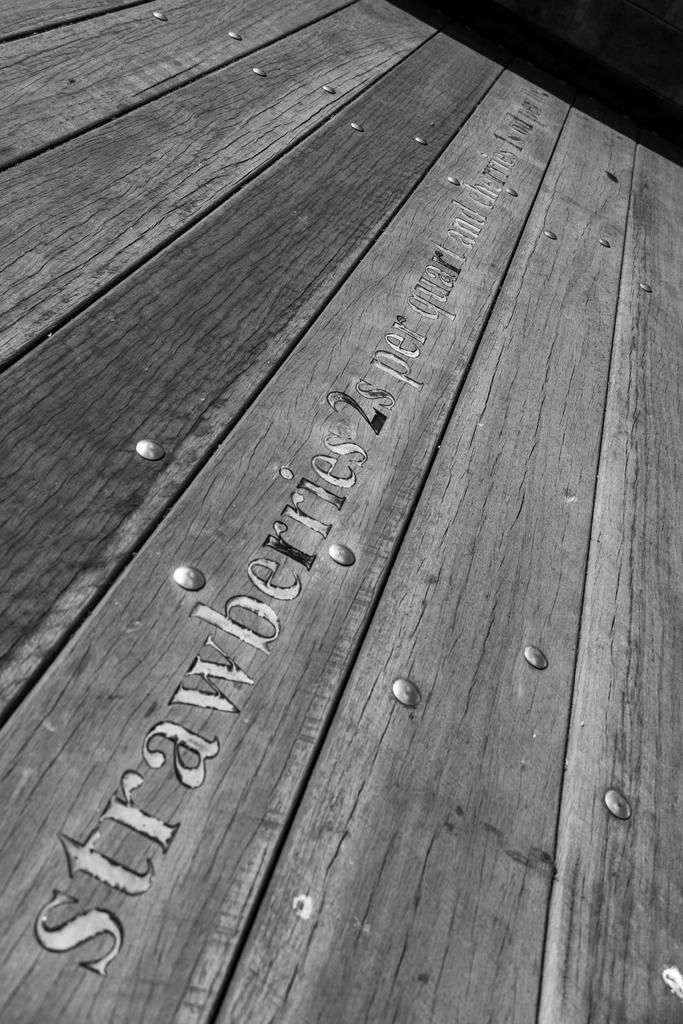<image>
Describe the image concisely. Strawberries stamped on a wooden crate on the side 